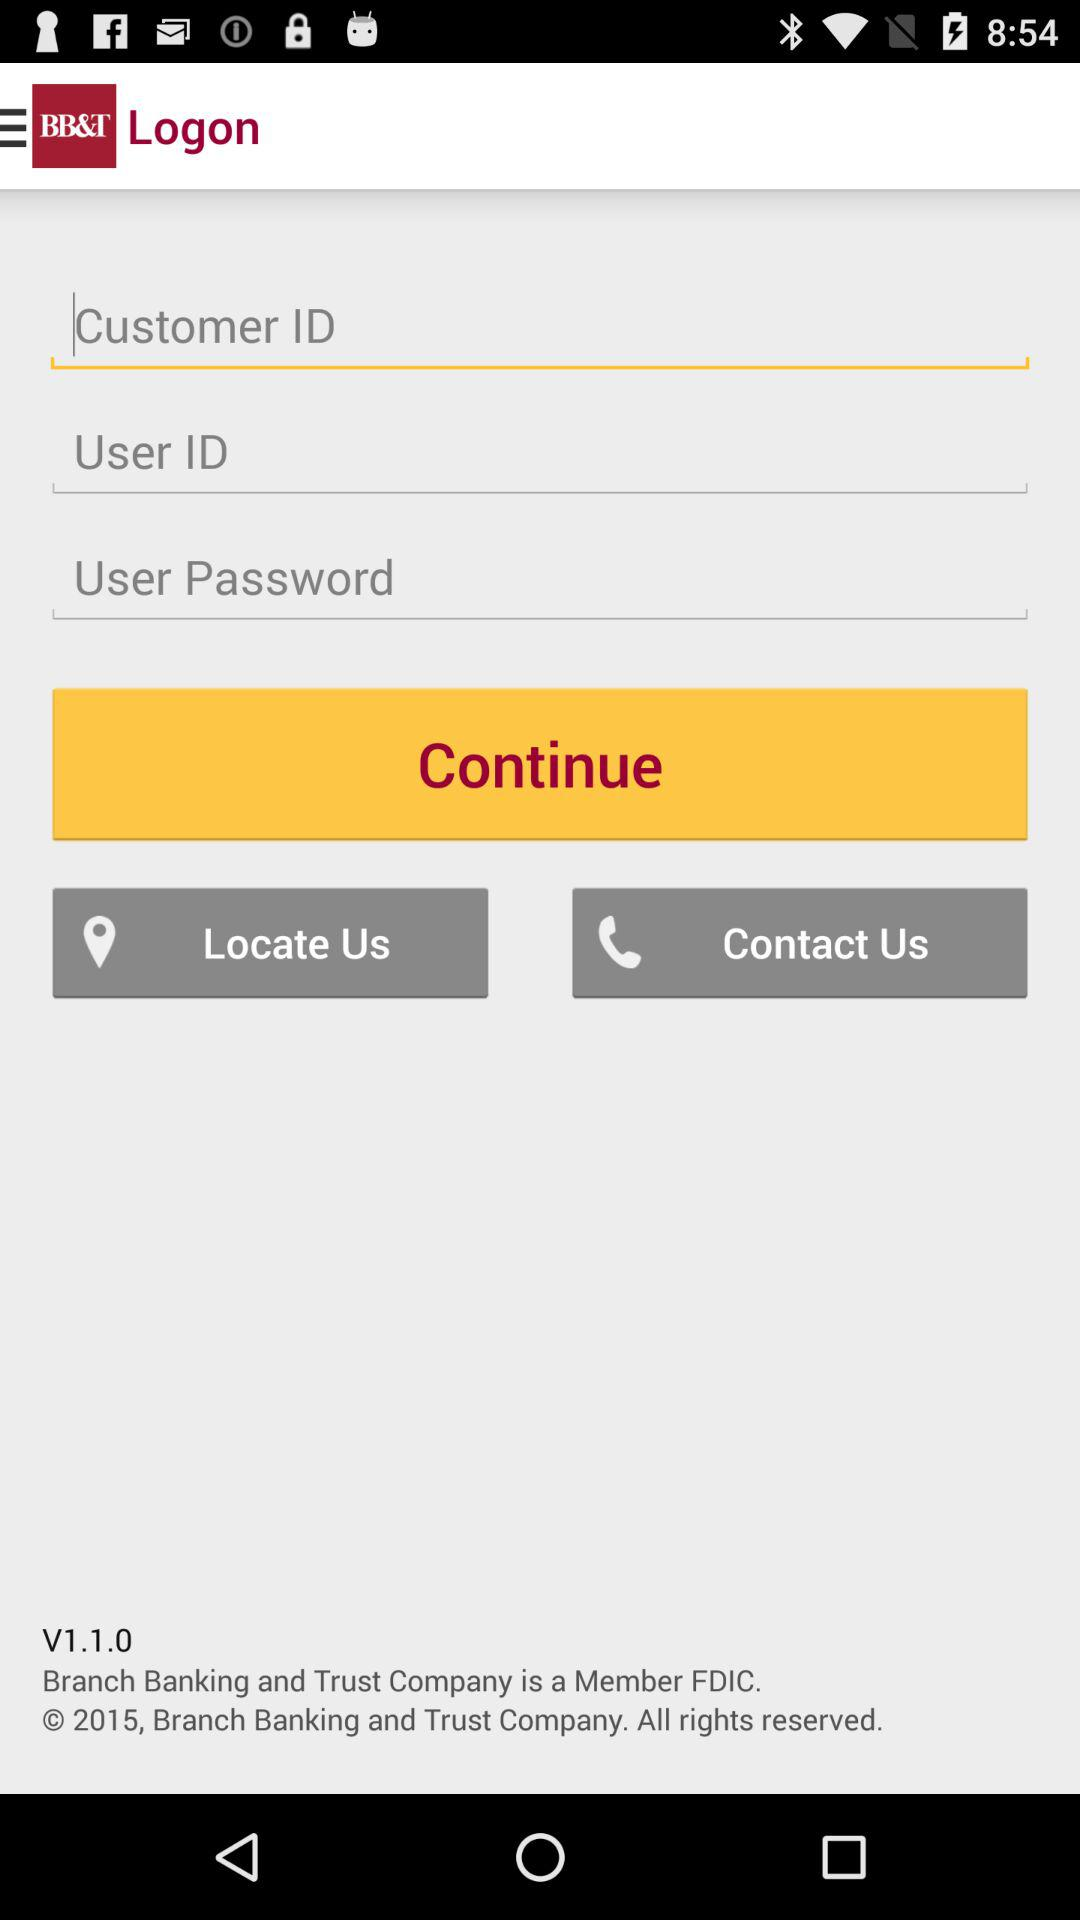What is the version of the app? The version of the app is V1.1.0. 